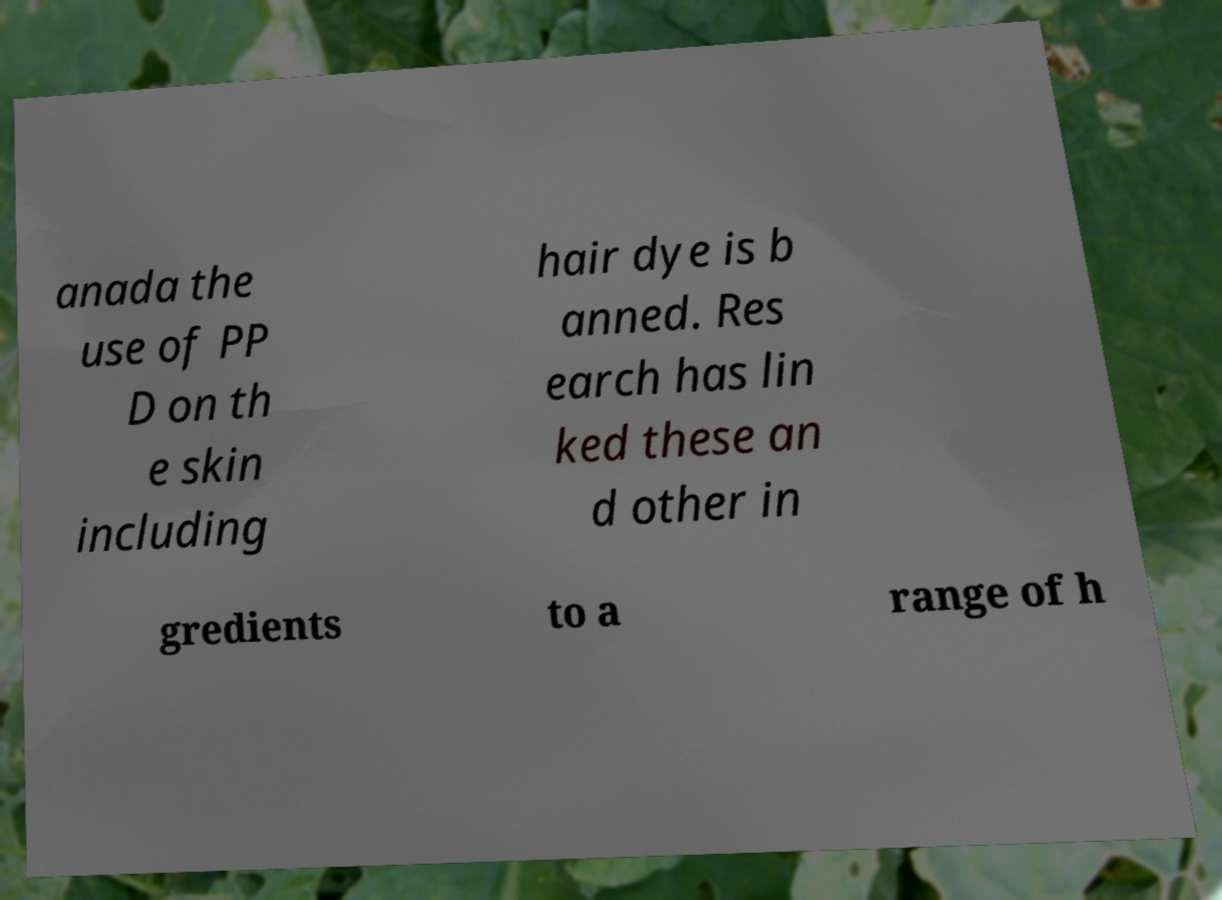Please read and relay the text visible in this image. What does it say? anada the use of PP D on th e skin including hair dye is b anned. Res earch has lin ked these an d other in gredients to a range of h 